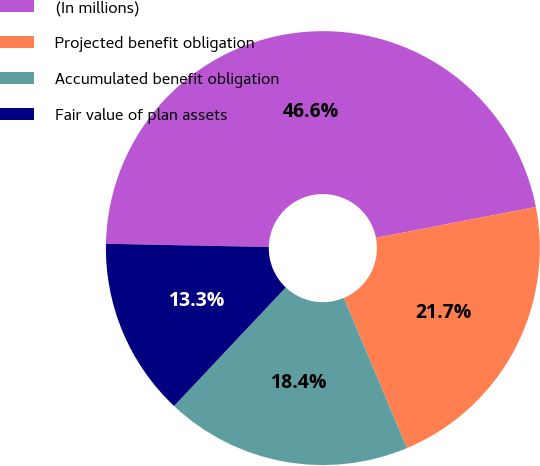<chart> <loc_0><loc_0><loc_500><loc_500><pie_chart><fcel>(In millions)<fcel>Projected benefit obligation<fcel>Accumulated benefit obligation<fcel>Fair value of plan assets<nl><fcel>46.64%<fcel>21.7%<fcel>18.36%<fcel>13.29%<nl></chart> 